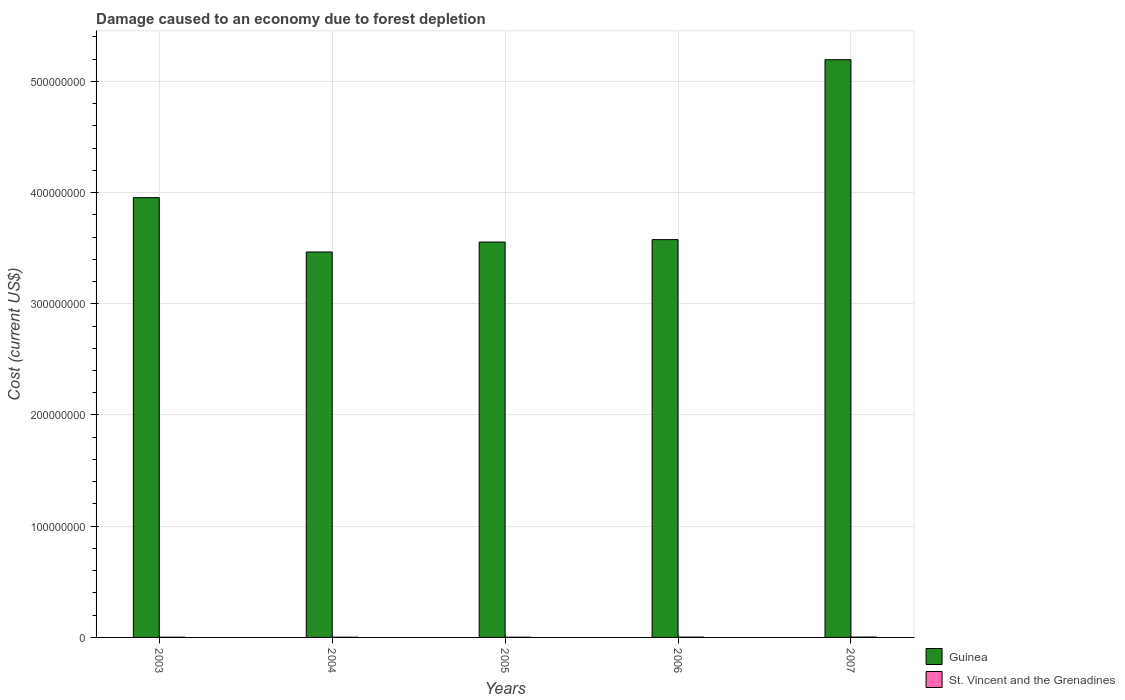Are the number of bars per tick equal to the number of legend labels?
Your answer should be compact. Yes. How many bars are there on the 2nd tick from the left?
Your answer should be compact. 2. How many bars are there on the 1st tick from the right?
Give a very brief answer. 2. What is the cost of damage caused due to forest depletion in St. Vincent and the Grenadines in 2004?
Offer a terse response. 2.01e+05. Across all years, what is the maximum cost of damage caused due to forest depletion in Guinea?
Your response must be concise. 5.19e+08. Across all years, what is the minimum cost of damage caused due to forest depletion in Guinea?
Keep it short and to the point. 3.47e+08. What is the total cost of damage caused due to forest depletion in St. Vincent and the Grenadines in the graph?
Your answer should be very brief. 1.18e+06. What is the difference between the cost of damage caused due to forest depletion in Guinea in 2003 and that in 2005?
Make the answer very short. 3.99e+07. What is the difference between the cost of damage caused due to forest depletion in St. Vincent and the Grenadines in 2006 and the cost of damage caused due to forest depletion in Guinea in 2004?
Offer a very short reply. -3.46e+08. What is the average cost of damage caused due to forest depletion in St. Vincent and the Grenadines per year?
Offer a terse response. 2.36e+05. In the year 2006, what is the difference between the cost of damage caused due to forest depletion in Guinea and cost of damage caused due to forest depletion in St. Vincent and the Grenadines?
Give a very brief answer. 3.57e+08. What is the ratio of the cost of damage caused due to forest depletion in St. Vincent and the Grenadines in 2003 to that in 2005?
Offer a very short reply. 1.03. Is the cost of damage caused due to forest depletion in Guinea in 2003 less than that in 2007?
Keep it short and to the point. Yes. Is the difference between the cost of damage caused due to forest depletion in Guinea in 2004 and 2005 greater than the difference between the cost of damage caused due to forest depletion in St. Vincent and the Grenadines in 2004 and 2005?
Offer a very short reply. No. What is the difference between the highest and the second highest cost of damage caused due to forest depletion in St. Vincent and the Grenadines?
Give a very brief answer. 3.62e+04. What is the difference between the highest and the lowest cost of damage caused due to forest depletion in St. Vincent and the Grenadines?
Make the answer very short. 1.26e+05. Is the sum of the cost of damage caused due to forest depletion in St. Vincent and the Grenadines in 2006 and 2007 greater than the maximum cost of damage caused due to forest depletion in Guinea across all years?
Offer a very short reply. No. What does the 1st bar from the left in 2005 represents?
Offer a very short reply. Guinea. What does the 1st bar from the right in 2007 represents?
Make the answer very short. St. Vincent and the Grenadines. How many bars are there?
Give a very brief answer. 10. How many years are there in the graph?
Your answer should be very brief. 5. What is the difference between two consecutive major ticks on the Y-axis?
Provide a succinct answer. 1.00e+08. Does the graph contain any zero values?
Your answer should be very brief. No. Where does the legend appear in the graph?
Keep it short and to the point. Bottom right. How many legend labels are there?
Offer a terse response. 2. How are the legend labels stacked?
Offer a very short reply. Vertical. What is the title of the graph?
Give a very brief answer. Damage caused to an economy due to forest depletion. Does "Grenada" appear as one of the legend labels in the graph?
Your answer should be very brief. No. What is the label or title of the Y-axis?
Provide a succinct answer. Cost (current US$). What is the Cost (current US$) of Guinea in 2003?
Offer a very short reply. 3.95e+08. What is the Cost (current US$) of St. Vincent and the Grenadines in 2003?
Offer a very short reply. 1.95e+05. What is the Cost (current US$) in Guinea in 2004?
Keep it short and to the point. 3.47e+08. What is the Cost (current US$) in St. Vincent and the Grenadines in 2004?
Offer a terse response. 2.01e+05. What is the Cost (current US$) of Guinea in 2005?
Provide a succinct answer. 3.55e+08. What is the Cost (current US$) of St. Vincent and the Grenadines in 2005?
Provide a short and direct response. 1.90e+05. What is the Cost (current US$) in Guinea in 2006?
Make the answer very short. 3.58e+08. What is the Cost (current US$) of St. Vincent and the Grenadines in 2006?
Your answer should be very brief. 2.79e+05. What is the Cost (current US$) in Guinea in 2007?
Keep it short and to the point. 5.19e+08. What is the Cost (current US$) of St. Vincent and the Grenadines in 2007?
Give a very brief answer. 3.16e+05. Across all years, what is the maximum Cost (current US$) of Guinea?
Offer a very short reply. 5.19e+08. Across all years, what is the maximum Cost (current US$) of St. Vincent and the Grenadines?
Offer a very short reply. 3.16e+05. Across all years, what is the minimum Cost (current US$) in Guinea?
Give a very brief answer. 3.47e+08. Across all years, what is the minimum Cost (current US$) in St. Vincent and the Grenadines?
Offer a terse response. 1.90e+05. What is the total Cost (current US$) of Guinea in the graph?
Make the answer very short. 1.97e+09. What is the total Cost (current US$) of St. Vincent and the Grenadines in the graph?
Give a very brief answer. 1.18e+06. What is the difference between the Cost (current US$) in Guinea in 2003 and that in 2004?
Give a very brief answer. 4.89e+07. What is the difference between the Cost (current US$) in St. Vincent and the Grenadines in 2003 and that in 2004?
Your answer should be very brief. -6508.81. What is the difference between the Cost (current US$) in Guinea in 2003 and that in 2005?
Keep it short and to the point. 3.99e+07. What is the difference between the Cost (current US$) in St. Vincent and the Grenadines in 2003 and that in 2005?
Make the answer very short. 4951.54. What is the difference between the Cost (current US$) of Guinea in 2003 and that in 2006?
Offer a very short reply. 3.77e+07. What is the difference between the Cost (current US$) of St. Vincent and the Grenadines in 2003 and that in 2006?
Your answer should be very brief. -8.46e+04. What is the difference between the Cost (current US$) of Guinea in 2003 and that in 2007?
Your answer should be very brief. -1.24e+08. What is the difference between the Cost (current US$) of St. Vincent and the Grenadines in 2003 and that in 2007?
Make the answer very short. -1.21e+05. What is the difference between the Cost (current US$) in Guinea in 2004 and that in 2005?
Provide a succinct answer. -8.93e+06. What is the difference between the Cost (current US$) in St. Vincent and the Grenadines in 2004 and that in 2005?
Make the answer very short. 1.15e+04. What is the difference between the Cost (current US$) of Guinea in 2004 and that in 2006?
Provide a short and direct response. -1.11e+07. What is the difference between the Cost (current US$) of St. Vincent and the Grenadines in 2004 and that in 2006?
Provide a short and direct response. -7.81e+04. What is the difference between the Cost (current US$) of Guinea in 2004 and that in 2007?
Make the answer very short. -1.73e+08. What is the difference between the Cost (current US$) in St. Vincent and the Grenadines in 2004 and that in 2007?
Offer a terse response. -1.14e+05. What is the difference between the Cost (current US$) in Guinea in 2005 and that in 2006?
Give a very brief answer. -2.19e+06. What is the difference between the Cost (current US$) in St. Vincent and the Grenadines in 2005 and that in 2006?
Offer a very short reply. -8.96e+04. What is the difference between the Cost (current US$) of Guinea in 2005 and that in 2007?
Offer a terse response. -1.64e+08. What is the difference between the Cost (current US$) of St. Vincent and the Grenadines in 2005 and that in 2007?
Offer a terse response. -1.26e+05. What is the difference between the Cost (current US$) in Guinea in 2006 and that in 2007?
Ensure brevity in your answer.  -1.62e+08. What is the difference between the Cost (current US$) in St. Vincent and the Grenadines in 2006 and that in 2007?
Provide a succinct answer. -3.62e+04. What is the difference between the Cost (current US$) in Guinea in 2003 and the Cost (current US$) in St. Vincent and the Grenadines in 2004?
Provide a succinct answer. 3.95e+08. What is the difference between the Cost (current US$) of Guinea in 2003 and the Cost (current US$) of St. Vincent and the Grenadines in 2005?
Provide a succinct answer. 3.95e+08. What is the difference between the Cost (current US$) of Guinea in 2003 and the Cost (current US$) of St. Vincent and the Grenadines in 2006?
Your response must be concise. 3.95e+08. What is the difference between the Cost (current US$) in Guinea in 2003 and the Cost (current US$) in St. Vincent and the Grenadines in 2007?
Provide a succinct answer. 3.95e+08. What is the difference between the Cost (current US$) of Guinea in 2004 and the Cost (current US$) of St. Vincent and the Grenadines in 2005?
Your answer should be very brief. 3.46e+08. What is the difference between the Cost (current US$) in Guinea in 2004 and the Cost (current US$) in St. Vincent and the Grenadines in 2006?
Provide a short and direct response. 3.46e+08. What is the difference between the Cost (current US$) of Guinea in 2004 and the Cost (current US$) of St. Vincent and the Grenadines in 2007?
Your answer should be very brief. 3.46e+08. What is the difference between the Cost (current US$) of Guinea in 2005 and the Cost (current US$) of St. Vincent and the Grenadines in 2006?
Keep it short and to the point. 3.55e+08. What is the difference between the Cost (current US$) of Guinea in 2005 and the Cost (current US$) of St. Vincent and the Grenadines in 2007?
Provide a short and direct response. 3.55e+08. What is the difference between the Cost (current US$) of Guinea in 2006 and the Cost (current US$) of St. Vincent and the Grenadines in 2007?
Make the answer very short. 3.57e+08. What is the average Cost (current US$) of Guinea per year?
Your response must be concise. 3.95e+08. What is the average Cost (current US$) in St. Vincent and the Grenadines per year?
Offer a very short reply. 2.36e+05. In the year 2003, what is the difference between the Cost (current US$) of Guinea and Cost (current US$) of St. Vincent and the Grenadines?
Ensure brevity in your answer.  3.95e+08. In the year 2004, what is the difference between the Cost (current US$) of Guinea and Cost (current US$) of St. Vincent and the Grenadines?
Make the answer very short. 3.46e+08. In the year 2005, what is the difference between the Cost (current US$) of Guinea and Cost (current US$) of St. Vincent and the Grenadines?
Provide a short and direct response. 3.55e+08. In the year 2006, what is the difference between the Cost (current US$) of Guinea and Cost (current US$) of St. Vincent and the Grenadines?
Keep it short and to the point. 3.57e+08. In the year 2007, what is the difference between the Cost (current US$) of Guinea and Cost (current US$) of St. Vincent and the Grenadines?
Ensure brevity in your answer.  5.19e+08. What is the ratio of the Cost (current US$) in Guinea in 2003 to that in 2004?
Your answer should be very brief. 1.14. What is the ratio of the Cost (current US$) of Guinea in 2003 to that in 2005?
Offer a terse response. 1.11. What is the ratio of the Cost (current US$) of St. Vincent and the Grenadines in 2003 to that in 2005?
Ensure brevity in your answer.  1.03. What is the ratio of the Cost (current US$) of Guinea in 2003 to that in 2006?
Your response must be concise. 1.11. What is the ratio of the Cost (current US$) in St. Vincent and the Grenadines in 2003 to that in 2006?
Offer a very short reply. 0.7. What is the ratio of the Cost (current US$) in Guinea in 2003 to that in 2007?
Make the answer very short. 0.76. What is the ratio of the Cost (current US$) of St. Vincent and the Grenadines in 2003 to that in 2007?
Ensure brevity in your answer.  0.62. What is the ratio of the Cost (current US$) in Guinea in 2004 to that in 2005?
Provide a short and direct response. 0.97. What is the ratio of the Cost (current US$) of St. Vincent and the Grenadines in 2004 to that in 2005?
Make the answer very short. 1.06. What is the ratio of the Cost (current US$) of Guinea in 2004 to that in 2006?
Provide a short and direct response. 0.97. What is the ratio of the Cost (current US$) of St. Vincent and the Grenadines in 2004 to that in 2006?
Offer a very short reply. 0.72. What is the ratio of the Cost (current US$) in Guinea in 2004 to that in 2007?
Provide a succinct answer. 0.67. What is the ratio of the Cost (current US$) of St. Vincent and the Grenadines in 2004 to that in 2007?
Provide a succinct answer. 0.64. What is the ratio of the Cost (current US$) of St. Vincent and the Grenadines in 2005 to that in 2006?
Offer a very short reply. 0.68. What is the ratio of the Cost (current US$) in Guinea in 2005 to that in 2007?
Provide a succinct answer. 0.68. What is the ratio of the Cost (current US$) of St. Vincent and the Grenadines in 2005 to that in 2007?
Keep it short and to the point. 0.6. What is the ratio of the Cost (current US$) of Guinea in 2006 to that in 2007?
Keep it short and to the point. 0.69. What is the ratio of the Cost (current US$) in St. Vincent and the Grenadines in 2006 to that in 2007?
Your answer should be compact. 0.89. What is the difference between the highest and the second highest Cost (current US$) in Guinea?
Your response must be concise. 1.24e+08. What is the difference between the highest and the second highest Cost (current US$) of St. Vincent and the Grenadines?
Your response must be concise. 3.62e+04. What is the difference between the highest and the lowest Cost (current US$) of Guinea?
Offer a very short reply. 1.73e+08. What is the difference between the highest and the lowest Cost (current US$) of St. Vincent and the Grenadines?
Give a very brief answer. 1.26e+05. 